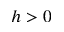<formula> <loc_0><loc_0><loc_500><loc_500>h > 0</formula> 